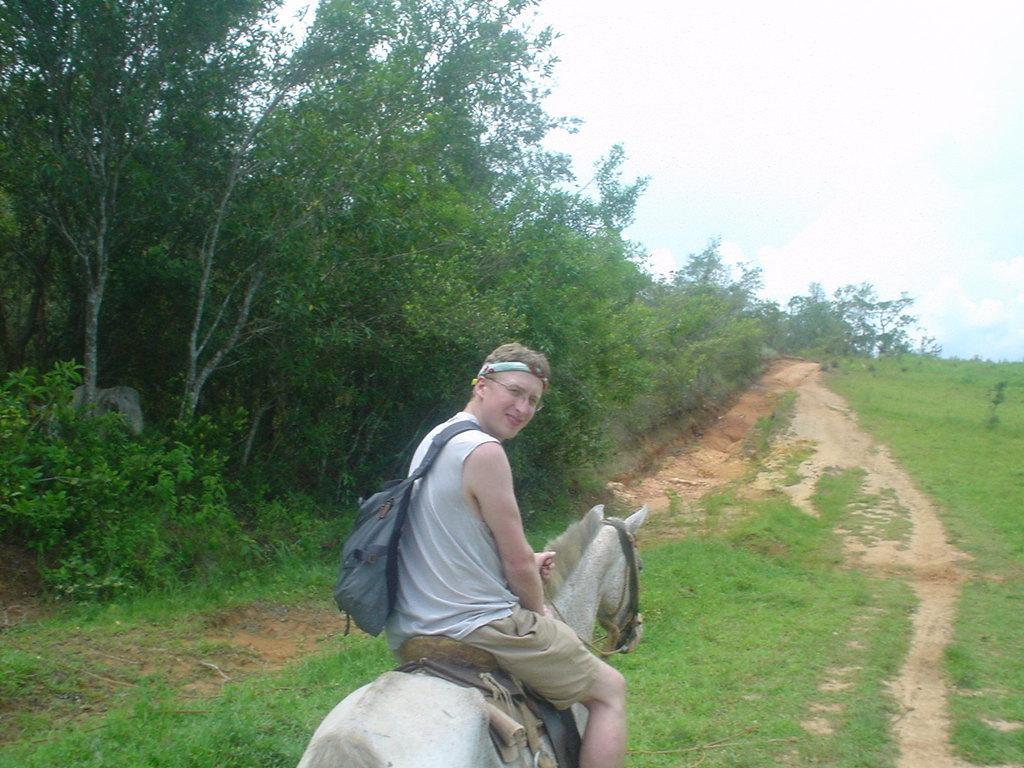Describe this image in one or two sentences. In this image we have a man who is sitting on the horse. The man is wearing white top and shorts. He is carrying a bag. In the left side of the image we have trees and on the right side of the image we can see a path and a blue sky. 